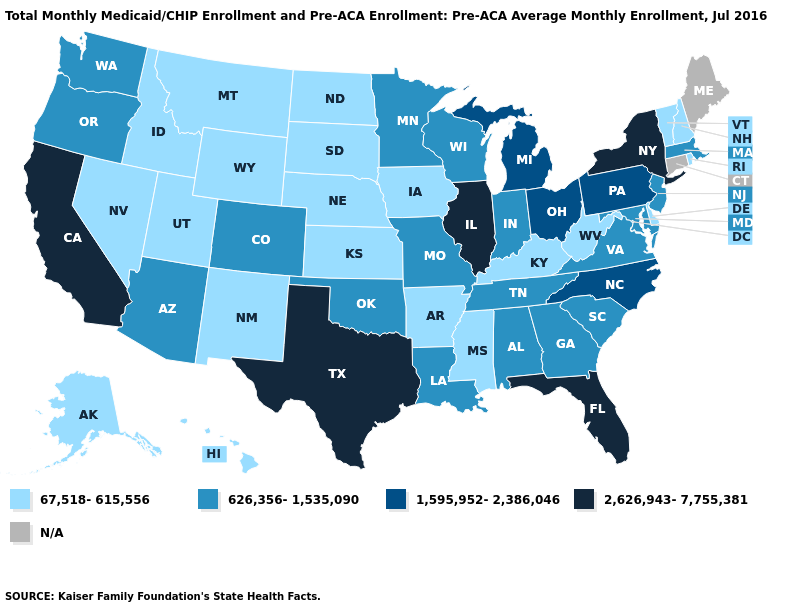What is the value of Wisconsin?
Write a very short answer. 626,356-1,535,090. Does New York have the highest value in the Northeast?
Answer briefly. Yes. Name the states that have a value in the range 1,595,952-2,386,046?
Answer briefly. Michigan, North Carolina, Ohio, Pennsylvania. What is the highest value in states that border Massachusetts?
Be succinct. 2,626,943-7,755,381. Among the states that border Tennessee , which have the highest value?
Keep it brief. North Carolina. What is the value of Delaware?
Quick response, please. 67,518-615,556. What is the lowest value in the USA?
Be succinct. 67,518-615,556. What is the value of Pennsylvania?
Keep it brief. 1,595,952-2,386,046. What is the value of Mississippi?
Keep it brief. 67,518-615,556. Which states hav the highest value in the West?
Quick response, please. California. Among the states that border Wyoming , does Utah have the lowest value?
Write a very short answer. Yes. Does Texas have the highest value in the USA?
Short answer required. Yes. Name the states that have a value in the range 67,518-615,556?
Quick response, please. Alaska, Arkansas, Delaware, Hawaii, Idaho, Iowa, Kansas, Kentucky, Mississippi, Montana, Nebraska, Nevada, New Hampshire, New Mexico, North Dakota, Rhode Island, South Dakota, Utah, Vermont, West Virginia, Wyoming. 